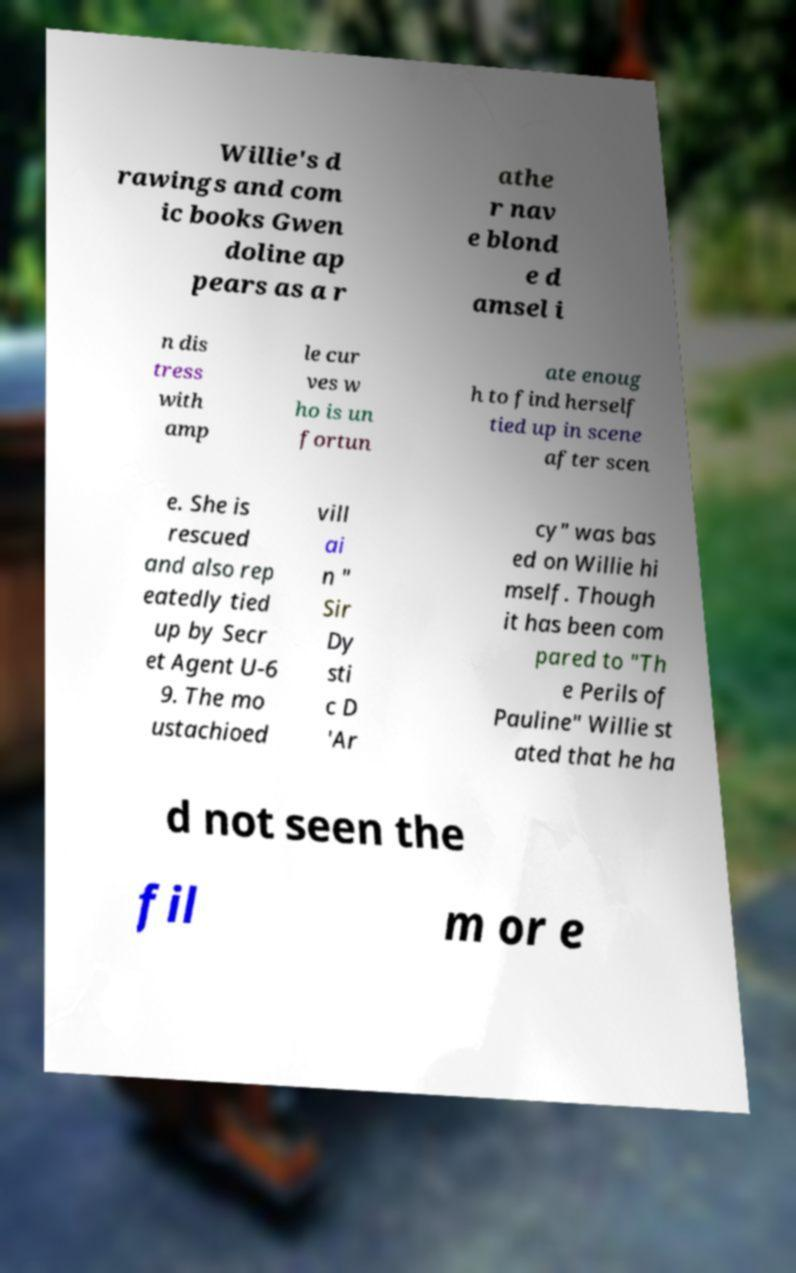Could you assist in decoding the text presented in this image and type it out clearly? Willie's d rawings and com ic books Gwen doline ap pears as a r athe r nav e blond e d amsel i n dis tress with amp le cur ves w ho is un fortun ate enoug h to find herself tied up in scene after scen e. She is rescued and also rep eatedly tied up by Secr et Agent U-6 9. The mo ustachioed vill ai n " Sir Dy sti c D 'Ar cy" was bas ed on Willie hi mself. Though it has been com pared to "Th e Perils of Pauline" Willie st ated that he ha d not seen the fil m or e 